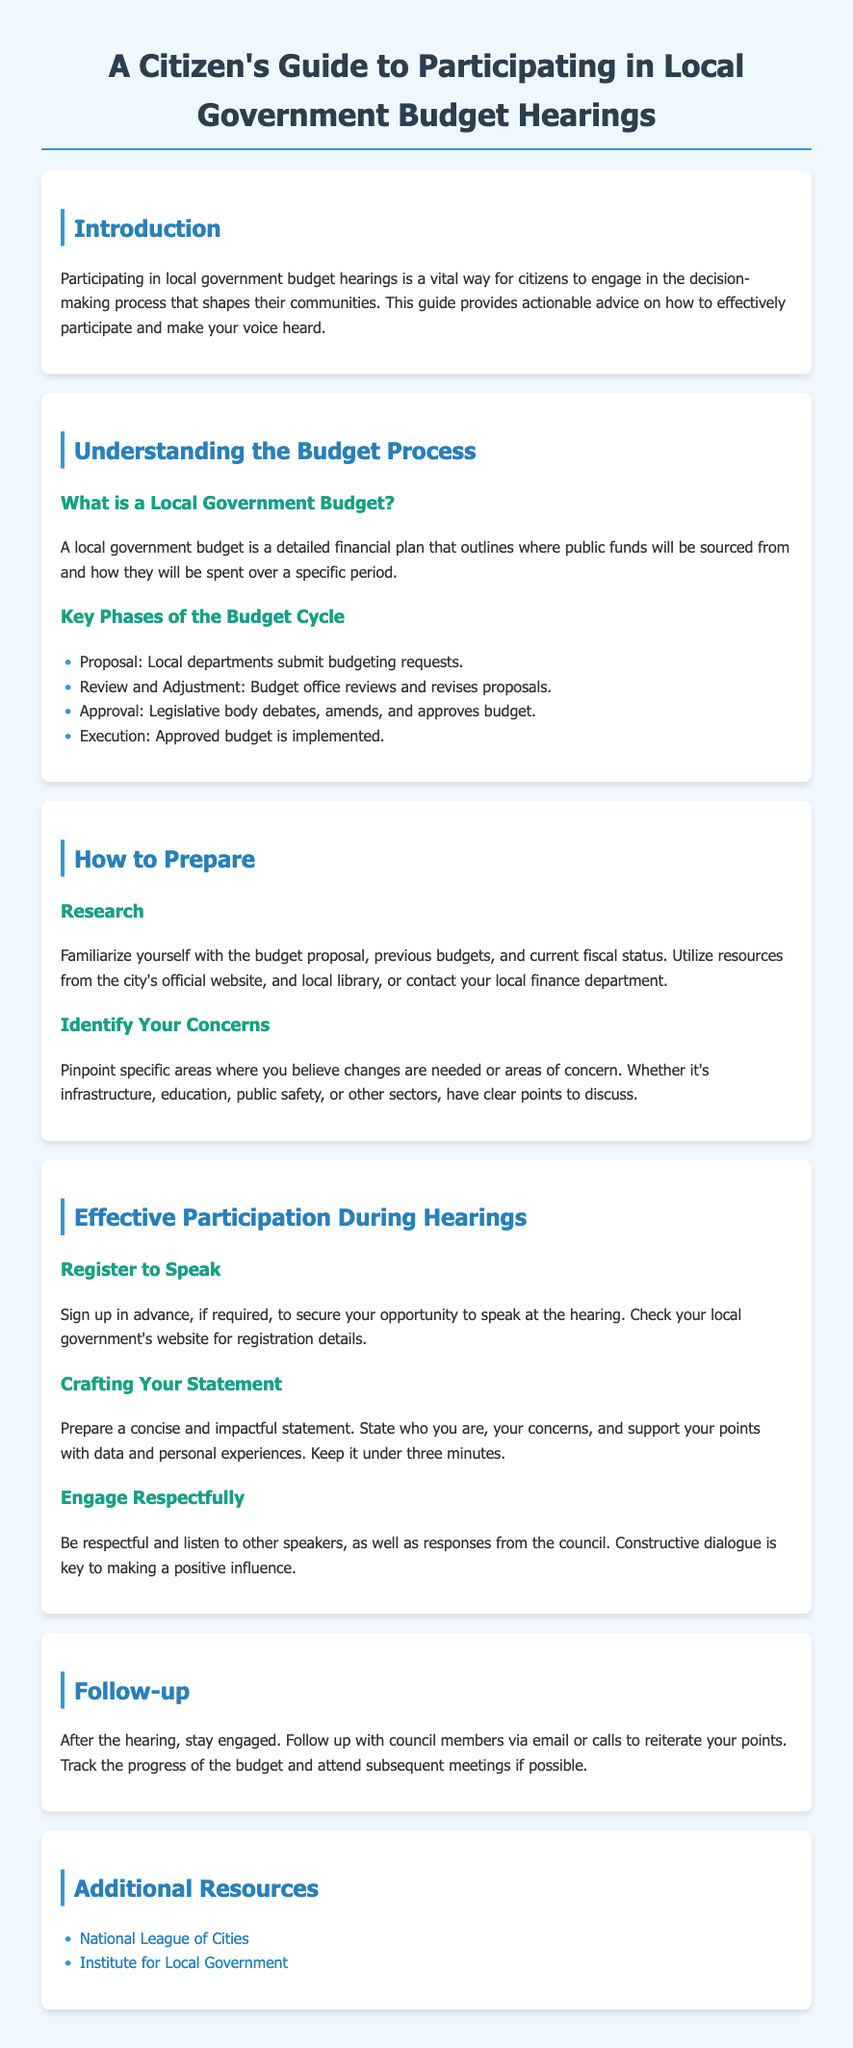What is the title of the guide? The title is the main heading of the document that indicates its purpose.
Answer: A Citizen's Guide to Participating in Local Government Budget Hearings What are the key phases of the budget cycle? The phases listed outline the sequential steps in the budget process according to the document.
Answer: Proposal, Review and Adjustment, Approval, Execution What should you prepare before the hearing? This refers to the actions that need to be taken according to the section on preparation.
Answer: Research and Identify Your Concerns How long should your statement be during the hearing? The document specifies a time limit for statements made during public hearings.
Answer: Under three minutes Which organization offers additional resources according to the document? This pertains to the organizations mentioned that provide further information on local government.
Answer: National League of Cities What is one way to stay engaged after the hearing? The document suggests actions to take after the public hearing to continue advocacy.
Answer: Follow up with council members What should you focus on when crafting your statement? This is about the content that should be included in your statement as advised by the document.
Answer: Concise and impactful statement What type of dialogue is encouraged during hearings? This refers to the manner in which participants should communicate during the hearings.
Answer: Constructive dialogue 